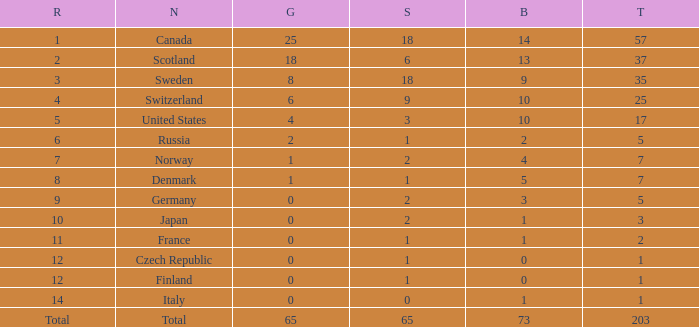What is the number of bronze medals when the total is greater than 1, more than 2 silver medals are won, and the rank is 2? 13.0. 